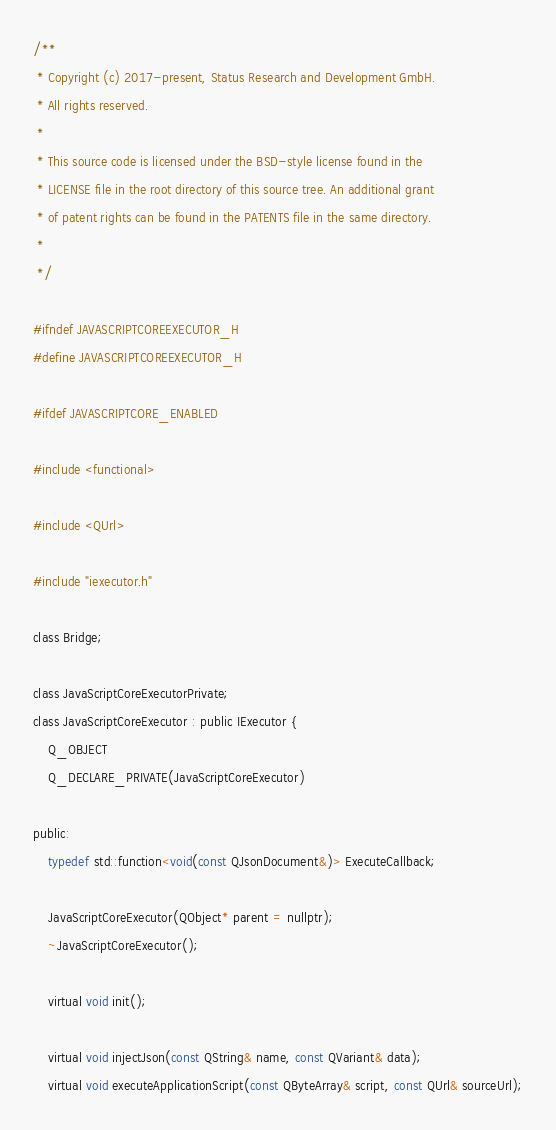Convert code to text. <code><loc_0><loc_0><loc_500><loc_500><_C_>
/**
 * Copyright (c) 2017-present, Status Research and Development GmbH.
 * All rights reserved.
 *
 * This source code is licensed under the BSD-style license found in the
 * LICENSE file in the root directory of this source tree. An additional grant
 * of patent rights can be found in the PATENTS file in the same directory.
 *
 */

#ifndef JAVASCRIPTCOREEXECUTOR_H
#define JAVASCRIPTCOREEXECUTOR_H

#ifdef JAVASCRIPTCORE_ENABLED

#include <functional>

#include <QUrl>

#include "iexecutor.h"

class Bridge;

class JavaScriptCoreExecutorPrivate;
class JavaScriptCoreExecutor : public IExecutor {
    Q_OBJECT
    Q_DECLARE_PRIVATE(JavaScriptCoreExecutor)

public:
    typedef std::function<void(const QJsonDocument&)> ExecuteCallback;

    JavaScriptCoreExecutor(QObject* parent = nullptr);
    ~JavaScriptCoreExecutor();

    virtual void init();

    virtual void injectJson(const QString& name, const QVariant& data);
    virtual void executeApplicationScript(const QByteArray& script, const QUrl& sourceUrl);</code> 